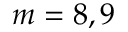<formula> <loc_0><loc_0><loc_500><loc_500>m = 8 , 9</formula> 